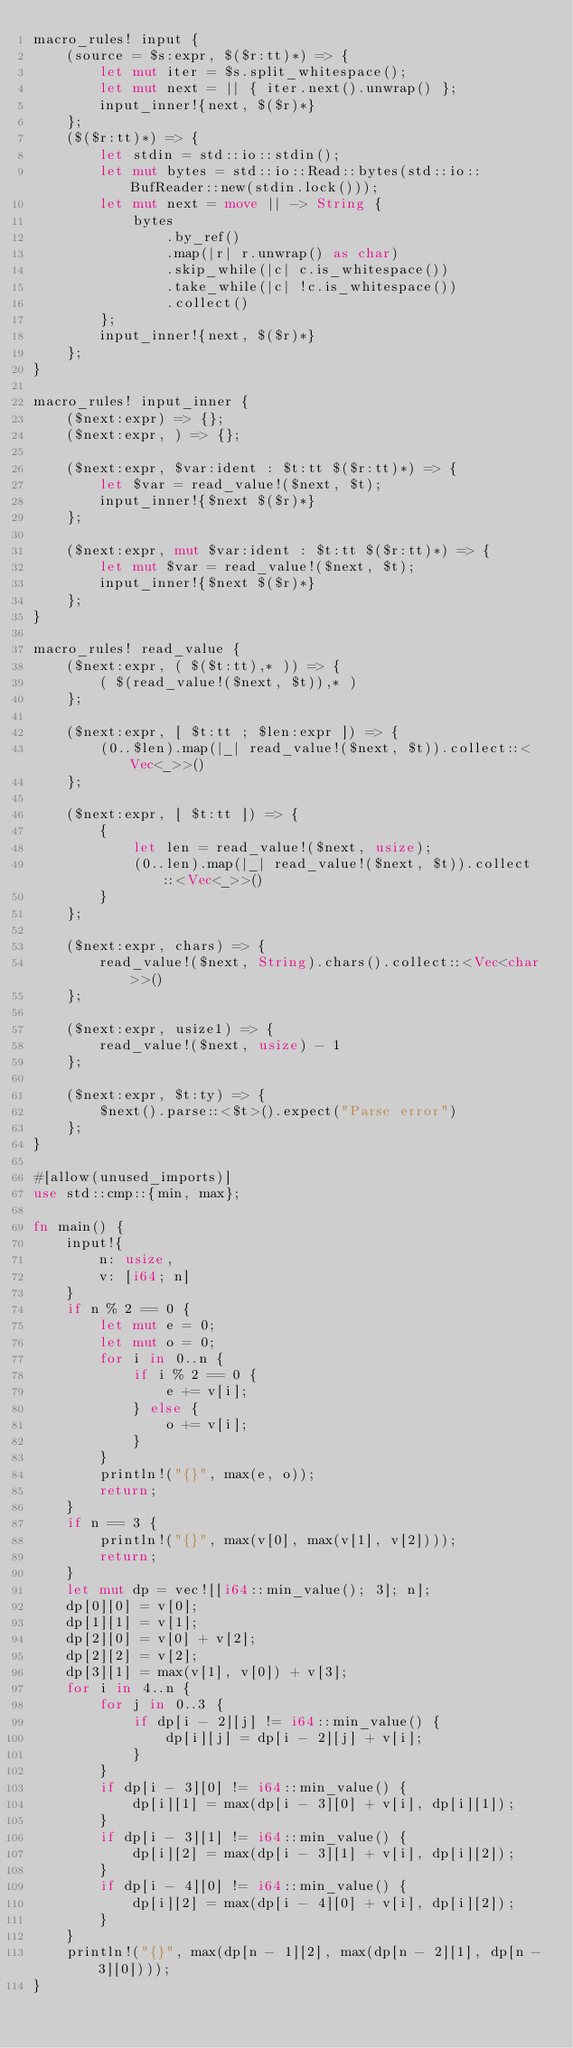Convert code to text. <code><loc_0><loc_0><loc_500><loc_500><_Rust_>macro_rules! input {
    (source = $s:expr, $($r:tt)*) => {
        let mut iter = $s.split_whitespace();
        let mut next = || { iter.next().unwrap() };
        input_inner!{next, $($r)*}
    };
    ($($r:tt)*) => {
        let stdin = std::io::stdin();
        let mut bytes = std::io::Read::bytes(std::io::BufReader::new(stdin.lock()));
        let mut next = move || -> String {
            bytes
                .by_ref()
                .map(|r| r.unwrap() as char)
                .skip_while(|c| c.is_whitespace())
                .take_while(|c| !c.is_whitespace())
                .collect()
        };
        input_inner!{next, $($r)*}
    };
}

macro_rules! input_inner {
    ($next:expr) => {};
    ($next:expr, ) => {};

    ($next:expr, $var:ident : $t:tt $($r:tt)*) => {
        let $var = read_value!($next, $t);
        input_inner!{$next $($r)*}
    };

    ($next:expr, mut $var:ident : $t:tt $($r:tt)*) => {
        let mut $var = read_value!($next, $t);
        input_inner!{$next $($r)*}
    };
}

macro_rules! read_value {
    ($next:expr, ( $($t:tt),* )) => {
        ( $(read_value!($next, $t)),* )
    };

    ($next:expr, [ $t:tt ; $len:expr ]) => {
        (0..$len).map(|_| read_value!($next, $t)).collect::<Vec<_>>()
    };

    ($next:expr, [ $t:tt ]) => {
        {
            let len = read_value!($next, usize);
            (0..len).map(|_| read_value!($next, $t)).collect::<Vec<_>>()
        }
    };

    ($next:expr, chars) => {
        read_value!($next, String).chars().collect::<Vec<char>>()
    };

    ($next:expr, usize1) => {
        read_value!($next, usize) - 1
    };

    ($next:expr, $t:ty) => {
        $next().parse::<$t>().expect("Parse error")
    };
}

#[allow(unused_imports)]
use std::cmp::{min, max};

fn main() {
    input!{
        n: usize,
        v: [i64; n]
    }
    if n % 2 == 0 {
        let mut e = 0;
        let mut o = 0;
        for i in 0..n {
            if i % 2 == 0 {
                e += v[i];
            } else {
                o += v[i];
            }
        }
        println!("{}", max(e, o));
        return;
    }
    if n == 3 {
        println!("{}", max(v[0], max(v[1], v[2])));
        return;
    }
    let mut dp = vec![[i64::min_value(); 3]; n];
    dp[0][0] = v[0];
    dp[1][1] = v[1];
    dp[2][0] = v[0] + v[2];
    dp[2][2] = v[2];
    dp[3][1] = max(v[1], v[0]) + v[3];
    for i in 4..n {
        for j in 0..3 {
            if dp[i - 2][j] != i64::min_value() {
                dp[i][j] = dp[i - 2][j] + v[i];
            }
        }
        if dp[i - 3][0] != i64::min_value() {
            dp[i][1] = max(dp[i - 3][0] + v[i], dp[i][1]);
        }
        if dp[i - 3][1] != i64::min_value() {
            dp[i][2] = max(dp[i - 3][1] + v[i], dp[i][2]);
        }
        if dp[i - 4][0] != i64::min_value() {
            dp[i][2] = max(dp[i - 4][0] + v[i], dp[i][2]);
        }
    }
    println!("{}", max(dp[n - 1][2], max(dp[n - 2][1], dp[n - 3][0])));
}
</code> 